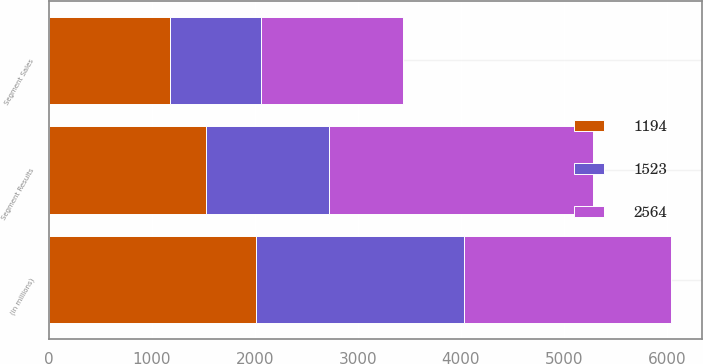<chart> <loc_0><loc_0><loc_500><loc_500><stacked_bar_chart><ecel><fcel>(in millions)<fcel>Segment Sales<fcel>Segment Results<nl><fcel>1523<fcel>2015<fcel>891<fcel>1194<nl><fcel>2564<fcel>2014<fcel>1373<fcel>2564<nl><fcel>1194<fcel>2013<fcel>1174<fcel>1523<nl></chart> 